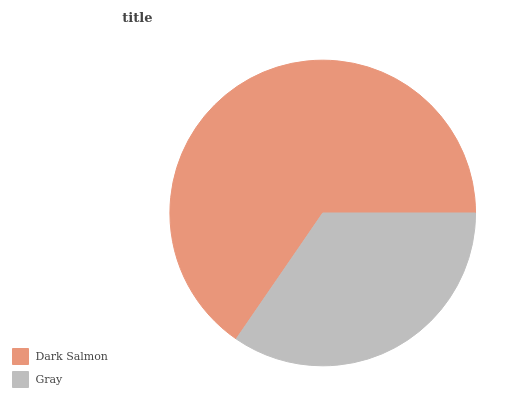Is Gray the minimum?
Answer yes or no. Yes. Is Dark Salmon the maximum?
Answer yes or no. Yes. Is Gray the maximum?
Answer yes or no. No. Is Dark Salmon greater than Gray?
Answer yes or no. Yes. Is Gray less than Dark Salmon?
Answer yes or no. Yes. Is Gray greater than Dark Salmon?
Answer yes or no. No. Is Dark Salmon less than Gray?
Answer yes or no. No. Is Dark Salmon the high median?
Answer yes or no. Yes. Is Gray the low median?
Answer yes or no. Yes. Is Gray the high median?
Answer yes or no. No. Is Dark Salmon the low median?
Answer yes or no. No. 